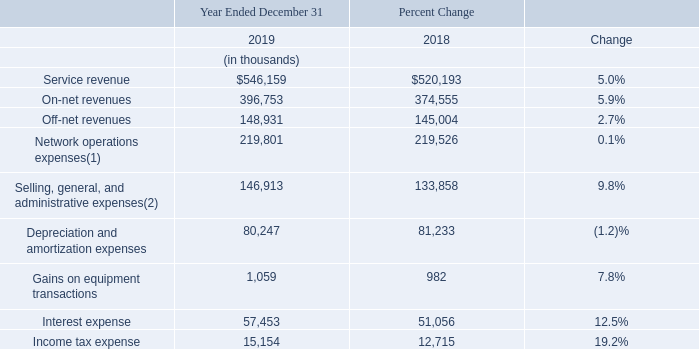Results of Operations
Year Ended December 31, 2019 Compared to the Year Ended December 31, 2018
Our management reviews and analyzes several key financial measures in order to manage our business and assess the quality of and variability of our service revenue, operating results and cash flows. The following summary tables present a comparison of our results of operations with respect to certain key financial measures. The comparisons illustrated in the tables are discussed in greater detail below.
(1) Includes non-cash equity-based compensation expense of $994 and $895 for 2019 and 2018, respectively.
(2) Includes non-cash equity-based compensation expense of $17,466 and $16,813 for 2019 and 2018, respectively.
Service Revenue. Our service revenue increased 5.0% from 2018 to 2019. Exchange rates negatively impacted our increase in service revenue by approximately $5.3 million. All foreign currency comparisons herein reflect results for 2019 translated at the average foreign currency exchange rates for 2018. We increased our total service revenue by increasing the number of sales representatives selling our services, by expanding our network, by adding additional buildings to our network, by increasing our penetration into the buildings connected to our network and by gaining market share by offering our services at lower prices than our competitors.
Revenue recognition standards include guidance relating to any tax assessed by a governmental authority that is directly imposed on a revenue-producing transaction between a seller and a customer and may include, but is not limited to, gross receipts taxes, Universal Service Fund fees and certain state regulatory fees. We record these taxes billed to our customers on a gross basis (as service revenue and network operations expense) in our consolidated statements of operations. The impact of these taxes including the Universal Service Fund resulted in an increase to our revenues from 2018 to 2019 of approximately $2.4 million.
Our net-centric customers tend to purchase their service on a price per megabit basis. Our corporate customers tend to utilize a small portion of their allocated bandwidth on their connections and tend to purchase their service on a per connection basis. Revenues from our corporate and net-centric customers represented 68.4% and 31.6% of total service revenue, respectively, for 2019 and represented 64.9% and 35.1% of total service revenue, respectively, for 2018. Revenues from corporate customers increased 10.6% to $373.7 million for 2019 from $337.8 million for 2018 primarily due to an increase in our number of our corporate customers. Revenues from our net-centric customers decreased by 5.4% to $172.5 million for 2019 from $182.3 million for 2018 primarily due to an increase in our number of net-centric customers being offset by a decline in our average price per megabit. Our revenue from our net-centric customers has declined as a percentage of our total revenue and grew at a slower rate than our corporate customer revenue because net-centric customers purchase our services based upon a price per megabit basis and our average price per megabit declined by 23.9% from 2018 to 2019. Additionally, the net-centric market experiences a greater level of pricing pressure than the corporate market and net-centric customers who renew their service with us expect their renewed service to be at a lower price than their current price. We expect that our average price per megabit will continue to decline at similar rates which would result in our corporate revenues continuing to represent a greater portion of our total revenues and our net-centric revenues continuing to grow at a lower rate than our corporate revenues. Additionally, the impact of foreign exchange rates has a more significant impact on our net-centric revenues.
Our on-net revenues increased 5.9% from 2018 to 2019. We increased the number of our on-net customer connections by 8.4% at December 31, 2019 from December 31, 2018. On-net customer connections increased at a greater rate than on-net revenues primarily due to the 3.8% decline in our on-net ARPU, primarily from a decline in ARPU for our net-centric customers. ARPU is determined by dividing revenue for the period by the average customer connections for that period. Our average price per megabit for our installed base of customers is determined by dividing the aggregate monthly recurring fixed charges for those customers by the aggregate committed data rate for the same customers. The decline in on-net ARPU is partly attributed to volume and term based pricing discounts. Additionally, on-net customers who cancel their service from our installed base of customers, in general, have an ARPU that is greater than the ARPU for our new customers due to declining prices primarily for our on-net services sold to our net-centric customers. These trends resulted in the reduction to our on-net ARPU and a 23.9% decline in our average price per megabit for our installed base of customers.
Our off-net revenues increased 2.7% from 2018 to 2019. Our off-net revenues increased as we increased the number of our off-net customer connections by 6.3% at December 31, 2019 from December 31, 2018. Our off-net customer connections increased at a greater rate than our off-net revenue primarily due to the 5.0% decrease in our off-net ARPU.
Network Operations Expenses. Network operations expenses include the costs of personnel associated with service delivery, network management, and customer support, network facilities costs, fiber and equipment maintenance fees, leased circuit costs, access and facilities fees paid to building owners and excise taxes billed to our customers and recorded on a gross basis. Non-cash equity-based compensation expense is included in network operations expenses consistent with the classification of the employee's salary and other compensation. Our network operations expenses, including non-cash equity-based compensation expense, increased 0.1% from 2018 to 2019 as we were connected to 8.0% more customer connections and we were connected to 125 more on-net buildings as of December 31, 2019 compared to December 31, 2018. The increase in network operations expense is primarily attributable to an increase in costs related to our network and facilities expansion activities, the increase in our off-net revenues and the increase in taxes recorded on a gross basis partly offset by price reductions obtained in certain of our circuit costs and fewer fiber operating leases. When we provide off-net services we also assume the cost of the associated tail circuits.
Selling, General, and Administrative Expenses (“SG&A”). Our SG&A expenses, including non-cash equity- based compensation expense, increased 9.8% from 2018 to 2019. Non-cash equity-based compensation expense is included in SG&A expenses consistent with the classification of the employee's salary and other compensation and was $17.5 million for 2019 and $16.8 million for 2018. SG&A expenses increased primarily from an increase in salaries and related costs required to support our expansion and increases in our sales efforts and an increase in our headcount. Our sales force headcount increased by 10.8% from 619 at December 31, 2018 to 686 at December 31, 2019 and our total headcount increased by 8.3% from 974 at December 31, 2018 to 1,055 at December 31, 2019.
Depreciation and Amortization Expenses. Our depreciation and amortization expenses decreased 1.2% from 2018 to 2019. The decrease is primarily due to the depreciation expense associated with the increase related to newly deployed fixed assets being offset by the decline in depreciation expense from fully depreciated fixed assets.
Gains on Equipment Transactions. We exchanged certain used network equipment and cash consideration for new network equipment resulting in gains of $1.1 million for 2019 and $1.0 million for 2018. The gains are based upon the excess of the estimated fair value of the new network equipment over the carrying amount of the returned used network equipment and the cash paid. The increase in gains from 2018 to 2019 was due to purchasing more equipment under the exchange program in 2019 than we purchased in 2018.
Interest Expense. Interest expense results from interest incurred on our $445.0 million of senior secured notes, interest incurred on our $189.2 million of senior unsecured notes, interest on our installment payment agreement, interest on our finance lease obligations and interest incurred on our €135.0 million of 2024 Notes that we issued on June 25, 2019. Our interest expense increased by 12.5% for 2019 from 2018 primarily due to the issuance of $70.0 million of senior secured notes we issued in August 2018, the issuance of €135.0 million of senior unsecured notes we issued in June 2019 and an increase in our finance lease obligations. The 2024 Notes were issued at par for €135.0 million ($153.7 million) on June 25, 2019. The 2024 Notes were issued in Euros and are reported in our reporting currency — US Dollars. As of December 31, 2019 the 2024 Notes were valued at $151.4 million resulting in an unrealized gain on foreign exchange of $2.3 million in 2019.
Income Tax Expense. Our income tax expense was $15.1 million for 2019 and $12.7 million for 2018. The increase in our income tax expense was primarily related to an increase in our income before income taxes.
Buildings On-net. As of December 31, 2019 and 2018 we had a total of 2,801 and 2,676 on-net buildings connected to our network, respectively.
What are the respective amounts of non-cash equity-based compensation expense included in the network operations expenses in 2018 and 2019 respectively?
Answer scale should be: thousand. $895, $994. What are the respective amounts of non-cash equity-based compensation expense included in the selling, general, and administrative expenses in 2018 and 2019 respectively?
Answer scale should be: thousand. $16,813, $17,466. What are the respective service revenue in 2018 and 2019?
Answer scale should be: thousand. $520,193, $546,159. What is the average service revenue in 2018 and 2019?
Answer scale should be: thousand. ($520,193 + $546,159)/2 
Answer: 533176. What is the average on-net revenue in 2018 and 2019?
Answer scale should be: thousand. (374,555 + 396,753)/2 
Answer: 385654. What is the average off-net revenue in 2018 and 2019?
Answer scale should be: thousand. (145,004 + 148,931)/2 
Answer: 146967.5. 